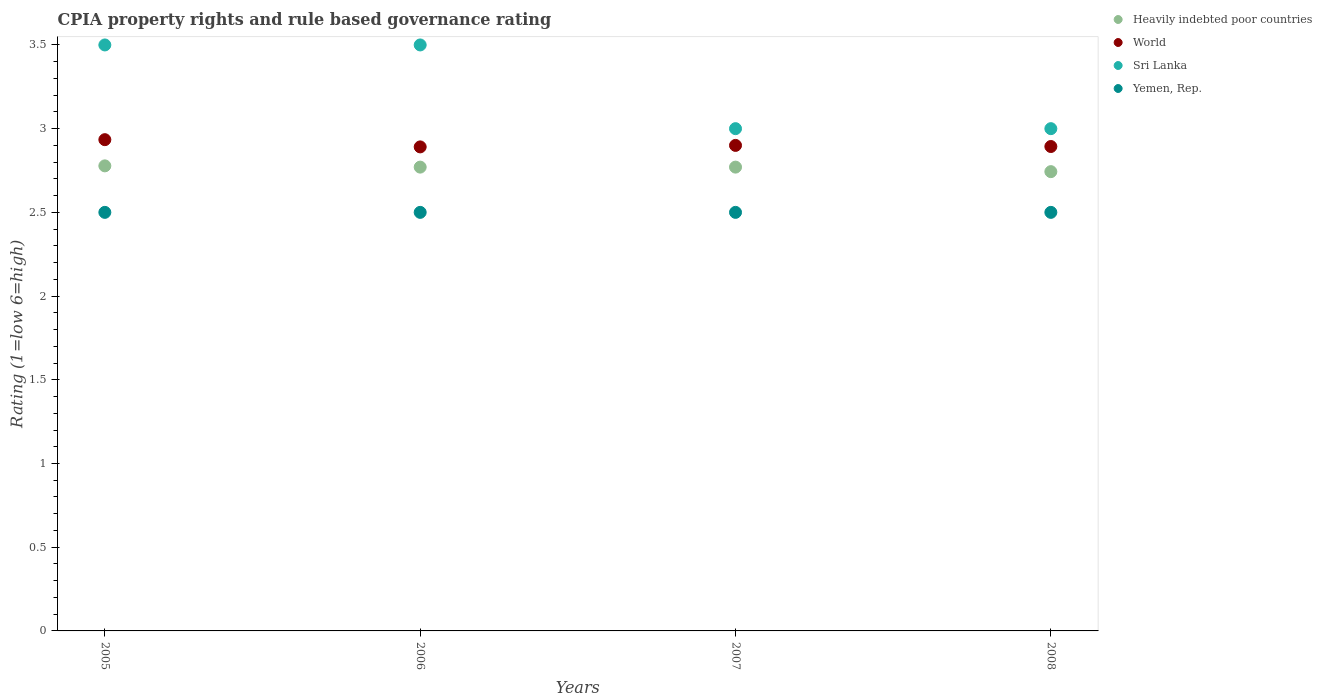How many different coloured dotlines are there?
Your answer should be very brief. 4. Is the number of dotlines equal to the number of legend labels?
Make the answer very short. Yes. What is the total CPIA rating in World in the graph?
Offer a terse response. 11.62. What is the difference between the CPIA rating in World in 2007 and that in 2008?
Ensure brevity in your answer.  0.01. What is the difference between the CPIA rating in Sri Lanka in 2006 and the CPIA rating in Heavily indebted poor countries in 2007?
Give a very brief answer. 0.73. In the year 2008, what is the difference between the CPIA rating in Heavily indebted poor countries and CPIA rating in Sri Lanka?
Give a very brief answer. -0.26. What is the ratio of the CPIA rating in Heavily indebted poor countries in 2005 to that in 2006?
Keep it short and to the point. 1. Is the CPIA rating in Yemen, Rep. in 2005 less than that in 2007?
Your answer should be very brief. No. Is the difference between the CPIA rating in Heavily indebted poor countries in 2005 and 2006 greater than the difference between the CPIA rating in Sri Lanka in 2005 and 2006?
Give a very brief answer. Yes. What is the difference between the highest and the second highest CPIA rating in Heavily indebted poor countries?
Your answer should be very brief. 0.01. What is the difference between the highest and the lowest CPIA rating in World?
Your answer should be compact. 0.04. In how many years, is the CPIA rating in Sri Lanka greater than the average CPIA rating in Sri Lanka taken over all years?
Keep it short and to the point. 2. Is the sum of the CPIA rating in Yemen, Rep. in 2005 and 2008 greater than the maximum CPIA rating in Sri Lanka across all years?
Your response must be concise. Yes. Is it the case that in every year, the sum of the CPIA rating in Heavily indebted poor countries and CPIA rating in Sri Lanka  is greater than the sum of CPIA rating in Yemen, Rep. and CPIA rating in World?
Ensure brevity in your answer.  No. Is it the case that in every year, the sum of the CPIA rating in World and CPIA rating in Yemen, Rep.  is greater than the CPIA rating in Sri Lanka?
Make the answer very short. Yes. Does the CPIA rating in World monotonically increase over the years?
Offer a very short reply. No. Is the CPIA rating in World strictly greater than the CPIA rating in Sri Lanka over the years?
Keep it short and to the point. No. How many years are there in the graph?
Your response must be concise. 4. What is the difference between two consecutive major ticks on the Y-axis?
Provide a succinct answer. 0.5. Are the values on the major ticks of Y-axis written in scientific E-notation?
Offer a terse response. No. Does the graph contain any zero values?
Provide a short and direct response. No. Does the graph contain grids?
Offer a very short reply. No. Where does the legend appear in the graph?
Provide a succinct answer. Top right. What is the title of the graph?
Your response must be concise. CPIA property rights and rule based governance rating. Does "Pakistan" appear as one of the legend labels in the graph?
Make the answer very short. No. What is the Rating (1=low 6=high) in Heavily indebted poor countries in 2005?
Ensure brevity in your answer.  2.78. What is the Rating (1=low 6=high) of World in 2005?
Provide a short and direct response. 2.93. What is the Rating (1=low 6=high) of Sri Lanka in 2005?
Offer a terse response. 3.5. What is the Rating (1=low 6=high) in Yemen, Rep. in 2005?
Provide a succinct answer. 2.5. What is the Rating (1=low 6=high) of Heavily indebted poor countries in 2006?
Your response must be concise. 2.77. What is the Rating (1=low 6=high) in World in 2006?
Your answer should be compact. 2.89. What is the Rating (1=low 6=high) of Sri Lanka in 2006?
Keep it short and to the point. 3.5. What is the Rating (1=low 6=high) in Heavily indebted poor countries in 2007?
Keep it short and to the point. 2.77. What is the Rating (1=low 6=high) in World in 2007?
Provide a succinct answer. 2.9. What is the Rating (1=low 6=high) of Heavily indebted poor countries in 2008?
Keep it short and to the point. 2.74. What is the Rating (1=low 6=high) of World in 2008?
Keep it short and to the point. 2.89. Across all years, what is the maximum Rating (1=low 6=high) in Heavily indebted poor countries?
Provide a succinct answer. 2.78. Across all years, what is the maximum Rating (1=low 6=high) of World?
Offer a very short reply. 2.93. Across all years, what is the maximum Rating (1=low 6=high) of Sri Lanka?
Offer a very short reply. 3.5. Across all years, what is the maximum Rating (1=low 6=high) of Yemen, Rep.?
Your answer should be compact. 2.5. Across all years, what is the minimum Rating (1=low 6=high) of Heavily indebted poor countries?
Make the answer very short. 2.74. Across all years, what is the minimum Rating (1=low 6=high) in World?
Your response must be concise. 2.89. Across all years, what is the minimum Rating (1=low 6=high) in Sri Lanka?
Your response must be concise. 3. What is the total Rating (1=low 6=high) of Heavily indebted poor countries in the graph?
Provide a succinct answer. 11.06. What is the total Rating (1=low 6=high) of World in the graph?
Your answer should be compact. 11.62. What is the difference between the Rating (1=low 6=high) in Heavily indebted poor countries in 2005 and that in 2006?
Your answer should be very brief. 0.01. What is the difference between the Rating (1=low 6=high) in World in 2005 and that in 2006?
Offer a terse response. 0.04. What is the difference between the Rating (1=low 6=high) of Sri Lanka in 2005 and that in 2006?
Offer a terse response. 0. What is the difference between the Rating (1=low 6=high) of Heavily indebted poor countries in 2005 and that in 2007?
Your answer should be compact. 0.01. What is the difference between the Rating (1=low 6=high) in World in 2005 and that in 2007?
Offer a terse response. 0.03. What is the difference between the Rating (1=low 6=high) of Sri Lanka in 2005 and that in 2007?
Ensure brevity in your answer.  0.5. What is the difference between the Rating (1=low 6=high) in Yemen, Rep. in 2005 and that in 2007?
Offer a very short reply. 0. What is the difference between the Rating (1=low 6=high) in Heavily indebted poor countries in 2005 and that in 2008?
Offer a terse response. 0.03. What is the difference between the Rating (1=low 6=high) of World in 2005 and that in 2008?
Keep it short and to the point. 0.04. What is the difference between the Rating (1=low 6=high) in Heavily indebted poor countries in 2006 and that in 2007?
Offer a very short reply. 0. What is the difference between the Rating (1=low 6=high) in World in 2006 and that in 2007?
Your response must be concise. -0.01. What is the difference between the Rating (1=low 6=high) of Yemen, Rep. in 2006 and that in 2007?
Ensure brevity in your answer.  0. What is the difference between the Rating (1=low 6=high) in Heavily indebted poor countries in 2006 and that in 2008?
Make the answer very short. 0.03. What is the difference between the Rating (1=low 6=high) in World in 2006 and that in 2008?
Your answer should be compact. -0. What is the difference between the Rating (1=low 6=high) of Sri Lanka in 2006 and that in 2008?
Give a very brief answer. 0.5. What is the difference between the Rating (1=low 6=high) of Heavily indebted poor countries in 2007 and that in 2008?
Give a very brief answer. 0.03. What is the difference between the Rating (1=low 6=high) of World in 2007 and that in 2008?
Keep it short and to the point. 0.01. What is the difference between the Rating (1=low 6=high) of Sri Lanka in 2007 and that in 2008?
Your answer should be compact. 0. What is the difference between the Rating (1=low 6=high) of Heavily indebted poor countries in 2005 and the Rating (1=low 6=high) of World in 2006?
Your answer should be very brief. -0.11. What is the difference between the Rating (1=low 6=high) of Heavily indebted poor countries in 2005 and the Rating (1=low 6=high) of Sri Lanka in 2006?
Make the answer very short. -0.72. What is the difference between the Rating (1=low 6=high) in Heavily indebted poor countries in 2005 and the Rating (1=low 6=high) in Yemen, Rep. in 2006?
Your answer should be very brief. 0.28. What is the difference between the Rating (1=low 6=high) of World in 2005 and the Rating (1=low 6=high) of Sri Lanka in 2006?
Your answer should be compact. -0.57. What is the difference between the Rating (1=low 6=high) of World in 2005 and the Rating (1=low 6=high) of Yemen, Rep. in 2006?
Offer a terse response. 0.43. What is the difference between the Rating (1=low 6=high) of Sri Lanka in 2005 and the Rating (1=low 6=high) of Yemen, Rep. in 2006?
Your answer should be very brief. 1. What is the difference between the Rating (1=low 6=high) of Heavily indebted poor countries in 2005 and the Rating (1=low 6=high) of World in 2007?
Offer a terse response. -0.12. What is the difference between the Rating (1=low 6=high) in Heavily indebted poor countries in 2005 and the Rating (1=low 6=high) in Sri Lanka in 2007?
Keep it short and to the point. -0.22. What is the difference between the Rating (1=low 6=high) in Heavily indebted poor countries in 2005 and the Rating (1=low 6=high) in Yemen, Rep. in 2007?
Provide a short and direct response. 0.28. What is the difference between the Rating (1=low 6=high) of World in 2005 and the Rating (1=low 6=high) of Sri Lanka in 2007?
Offer a very short reply. -0.07. What is the difference between the Rating (1=low 6=high) of World in 2005 and the Rating (1=low 6=high) of Yemen, Rep. in 2007?
Ensure brevity in your answer.  0.43. What is the difference between the Rating (1=low 6=high) in Heavily indebted poor countries in 2005 and the Rating (1=low 6=high) in World in 2008?
Ensure brevity in your answer.  -0.12. What is the difference between the Rating (1=low 6=high) of Heavily indebted poor countries in 2005 and the Rating (1=low 6=high) of Sri Lanka in 2008?
Your answer should be very brief. -0.22. What is the difference between the Rating (1=low 6=high) in Heavily indebted poor countries in 2005 and the Rating (1=low 6=high) in Yemen, Rep. in 2008?
Make the answer very short. 0.28. What is the difference between the Rating (1=low 6=high) in World in 2005 and the Rating (1=low 6=high) in Sri Lanka in 2008?
Ensure brevity in your answer.  -0.07. What is the difference between the Rating (1=low 6=high) of World in 2005 and the Rating (1=low 6=high) of Yemen, Rep. in 2008?
Offer a terse response. 0.43. What is the difference between the Rating (1=low 6=high) in Heavily indebted poor countries in 2006 and the Rating (1=low 6=high) in World in 2007?
Give a very brief answer. -0.13. What is the difference between the Rating (1=low 6=high) in Heavily indebted poor countries in 2006 and the Rating (1=low 6=high) in Sri Lanka in 2007?
Make the answer very short. -0.23. What is the difference between the Rating (1=low 6=high) in Heavily indebted poor countries in 2006 and the Rating (1=low 6=high) in Yemen, Rep. in 2007?
Give a very brief answer. 0.27. What is the difference between the Rating (1=low 6=high) of World in 2006 and the Rating (1=low 6=high) of Sri Lanka in 2007?
Offer a very short reply. -0.11. What is the difference between the Rating (1=low 6=high) in World in 2006 and the Rating (1=low 6=high) in Yemen, Rep. in 2007?
Provide a succinct answer. 0.39. What is the difference between the Rating (1=low 6=high) of Heavily indebted poor countries in 2006 and the Rating (1=low 6=high) of World in 2008?
Provide a succinct answer. -0.12. What is the difference between the Rating (1=low 6=high) in Heavily indebted poor countries in 2006 and the Rating (1=low 6=high) in Sri Lanka in 2008?
Make the answer very short. -0.23. What is the difference between the Rating (1=low 6=high) in Heavily indebted poor countries in 2006 and the Rating (1=low 6=high) in Yemen, Rep. in 2008?
Make the answer very short. 0.27. What is the difference between the Rating (1=low 6=high) in World in 2006 and the Rating (1=low 6=high) in Sri Lanka in 2008?
Your answer should be very brief. -0.11. What is the difference between the Rating (1=low 6=high) of World in 2006 and the Rating (1=low 6=high) of Yemen, Rep. in 2008?
Make the answer very short. 0.39. What is the difference between the Rating (1=low 6=high) in Sri Lanka in 2006 and the Rating (1=low 6=high) in Yemen, Rep. in 2008?
Your response must be concise. 1. What is the difference between the Rating (1=low 6=high) in Heavily indebted poor countries in 2007 and the Rating (1=low 6=high) in World in 2008?
Provide a short and direct response. -0.12. What is the difference between the Rating (1=low 6=high) in Heavily indebted poor countries in 2007 and the Rating (1=low 6=high) in Sri Lanka in 2008?
Your response must be concise. -0.23. What is the difference between the Rating (1=low 6=high) in Heavily indebted poor countries in 2007 and the Rating (1=low 6=high) in Yemen, Rep. in 2008?
Your answer should be very brief. 0.27. What is the difference between the Rating (1=low 6=high) in Sri Lanka in 2007 and the Rating (1=low 6=high) in Yemen, Rep. in 2008?
Provide a succinct answer. 0.5. What is the average Rating (1=low 6=high) of Heavily indebted poor countries per year?
Provide a succinct answer. 2.77. What is the average Rating (1=low 6=high) in World per year?
Provide a short and direct response. 2.9. In the year 2005, what is the difference between the Rating (1=low 6=high) of Heavily indebted poor countries and Rating (1=low 6=high) of World?
Keep it short and to the point. -0.16. In the year 2005, what is the difference between the Rating (1=low 6=high) of Heavily indebted poor countries and Rating (1=low 6=high) of Sri Lanka?
Your answer should be compact. -0.72. In the year 2005, what is the difference between the Rating (1=low 6=high) in Heavily indebted poor countries and Rating (1=low 6=high) in Yemen, Rep.?
Keep it short and to the point. 0.28. In the year 2005, what is the difference between the Rating (1=low 6=high) in World and Rating (1=low 6=high) in Sri Lanka?
Make the answer very short. -0.57. In the year 2005, what is the difference between the Rating (1=low 6=high) of World and Rating (1=low 6=high) of Yemen, Rep.?
Your answer should be compact. 0.43. In the year 2005, what is the difference between the Rating (1=low 6=high) in Sri Lanka and Rating (1=low 6=high) in Yemen, Rep.?
Offer a very short reply. 1. In the year 2006, what is the difference between the Rating (1=low 6=high) in Heavily indebted poor countries and Rating (1=low 6=high) in World?
Provide a succinct answer. -0.12. In the year 2006, what is the difference between the Rating (1=low 6=high) in Heavily indebted poor countries and Rating (1=low 6=high) in Sri Lanka?
Ensure brevity in your answer.  -0.73. In the year 2006, what is the difference between the Rating (1=low 6=high) in Heavily indebted poor countries and Rating (1=low 6=high) in Yemen, Rep.?
Your answer should be very brief. 0.27. In the year 2006, what is the difference between the Rating (1=low 6=high) in World and Rating (1=low 6=high) in Sri Lanka?
Ensure brevity in your answer.  -0.61. In the year 2006, what is the difference between the Rating (1=low 6=high) of World and Rating (1=low 6=high) of Yemen, Rep.?
Your response must be concise. 0.39. In the year 2006, what is the difference between the Rating (1=low 6=high) of Sri Lanka and Rating (1=low 6=high) of Yemen, Rep.?
Offer a very short reply. 1. In the year 2007, what is the difference between the Rating (1=low 6=high) in Heavily indebted poor countries and Rating (1=low 6=high) in World?
Offer a very short reply. -0.13. In the year 2007, what is the difference between the Rating (1=low 6=high) in Heavily indebted poor countries and Rating (1=low 6=high) in Sri Lanka?
Provide a succinct answer. -0.23. In the year 2007, what is the difference between the Rating (1=low 6=high) of Heavily indebted poor countries and Rating (1=low 6=high) of Yemen, Rep.?
Your response must be concise. 0.27. In the year 2007, what is the difference between the Rating (1=low 6=high) in World and Rating (1=low 6=high) in Sri Lanka?
Provide a succinct answer. -0.1. In the year 2007, what is the difference between the Rating (1=low 6=high) in Sri Lanka and Rating (1=low 6=high) in Yemen, Rep.?
Ensure brevity in your answer.  0.5. In the year 2008, what is the difference between the Rating (1=low 6=high) in Heavily indebted poor countries and Rating (1=low 6=high) in World?
Your answer should be very brief. -0.15. In the year 2008, what is the difference between the Rating (1=low 6=high) in Heavily indebted poor countries and Rating (1=low 6=high) in Sri Lanka?
Make the answer very short. -0.26. In the year 2008, what is the difference between the Rating (1=low 6=high) in Heavily indebted poor countries and Rating (1=low 6=high) in Yemen, Rep.?
Give a very brief answer. 0.24. In the year 2008, what is the difference between the Rating (1=low 6=high) in World and Rating (1=low 6=high) in Sri Lanka?
Make the answer very short. -0.11. In the year 2008, what is the difference between the Rating (1=low 6=high) in World and Rating (1=low 6=high) in Yemen, Rep.?
Ensure brevity in your answer.  0.39. What is the ratio of the Rating (1=low 6=high) in Heavily indebted poor countries in 2005 to that in 2006?
Keep it short and to the point. 1. What is the ratio of the Rating (1=low 6=high) in World in 2005 to that in 2006?
Ensure brevity in your answer.  1.01. What is the ratio of the Rating (1=low 6=high) in Sri Lanka in 2005 to that in 2006?
Your response must be concise. 1. What is the ratio of the Rating (1=low 6=high) of Heavily indebted poor countries in 2005 to that in 2007?
Provide a short and direct response. 1. What is the ratio of the Rating (1=low 6=high) of World in 2005 to that in 2007?
Offer a terse response. 1.01. What is the ratio of the Rating (1=low 6=high) of Sri Lanka in 2005 to that in 2007?
Your response must be concise. 1.17. What is the ratio of the Rating (1=low 6=high) of Heavily indebted poor countries in 2005 to that in 2008?
Make the answer very short. 1.01. What is the ratio of the Rating (1=low 6=high) in World in 2005 to that in 2008?
Offer a terse response. 1.01. What is the ratio of the Rating (1=low 6=high) in Sri Lanka in 2005 to that in 2008?
Provide a short and direct response. 1.17. What is the ratio of the Rating (1=low 6=high) in World in 2006 to that in 2007?
Offer a very short reply. 1. What is the ratio of the Rating (1=low 6=high) in Sri Lanka in 2006 to that in 2007?
Ensure brevity in your answer.  1.17. What is the ratio of the Rating (1=low 6=high) of Yemen, Rep. in 2006 to that in 2007?
Offer a very short reply. 1. What is the ratio of the Rating (1=low 6=high) in Heavily indebted poor countries in 2006 to that in 2008?
Offer a terse response. 1.01. What is the ratio of the Rating (1=low 6=high) in World in 2006 to that in 2008?
Provide a short and direct response. 1. What is the ratio of the Rating (1=low 6=high) in Yemen, Rep. in 2006 to that in 2008?
Your response must be concise. 1. What is the ratio of the Rating (1=low 6=high) of Heavily indebted poor countries in 2007 to that in 2008?
Keep it short and to the point. 1.01. What is the ratio of the Rating (1=low 6=high) of World in 2007 to that in 2008?
Provide a succinct answer. 1. What is the ratio of the Rating (1=low 6=high) of Sri Lanka in 2007 to that in 2008?
Your answer should be compact. 1. What is the difference between the highest and the second highest Rating (1=low 6=high) in Heavily indebted poor countries?
Ensure brevity in your answer.  0.01. What is the difference between the highest and the second highest Rating (1=low 6=high) of World?
Your response must be concise. 0.03. What is the difference between the highest and the second highest Rating (1=low 6=high) in Yemen, Rep.?
Your answer should be compact. 0. What is the difference between the highest and the lowest Rating (1=low 6=high) of Heavily indebted poor countries?
Provide a short and direct response. 0.03. What is the difference between the highest and the lowest Rating (1=low 6=high) in World?
Offer a very short reply. 0.04. What is the difference between the highest and the lowest Rating (1=low 6=high) of Sri Lanka?
Offer a terse response. 0.5. What is the difference between the highest and the lowest Rating (1=low 6=high) in Yemen, Rep.?
Your response must be concise. 0. 